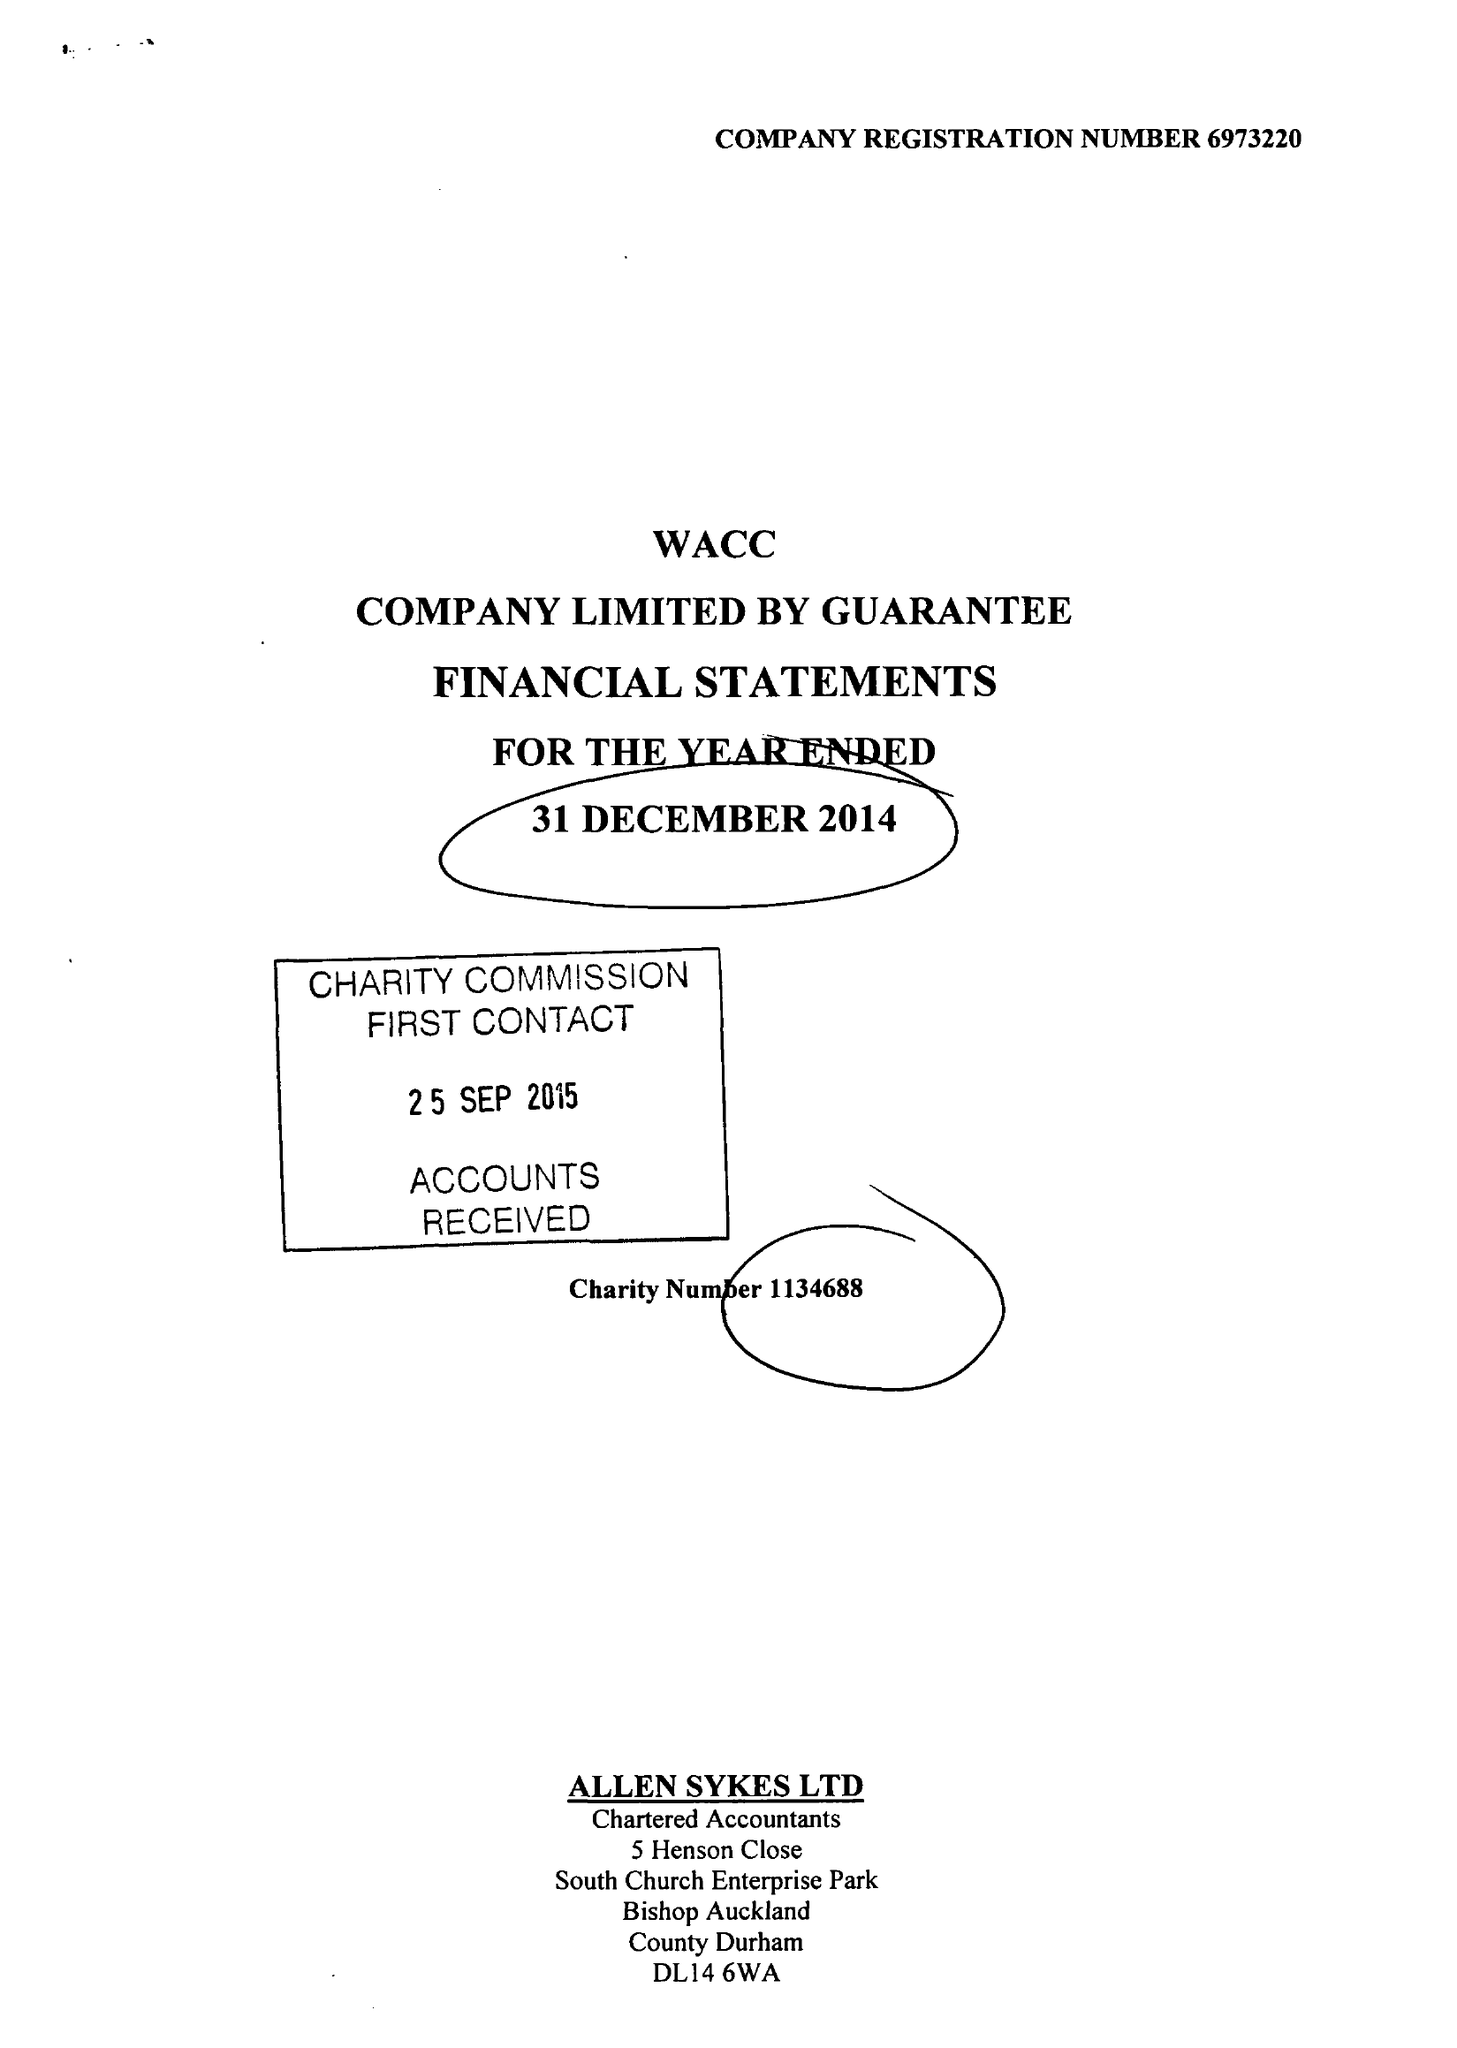What is the value for the income_annually_in_british_pounds?
Answer the question using a single word or phrase. 114404.00 